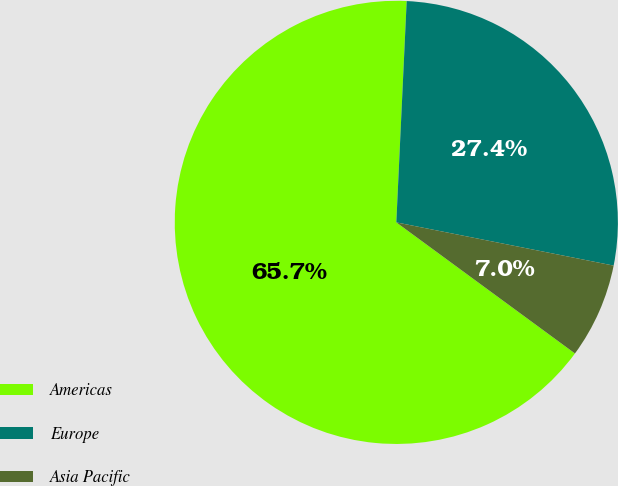<chart> <loc_0><loc_0><loc_500><loc_500><pie_chart><fcel>Americas<fcel>Europe<fcel>Asia Pacific<nl><fcel>65.67%<fcel>27.38%<fcel>6.95%<nl></chart> 